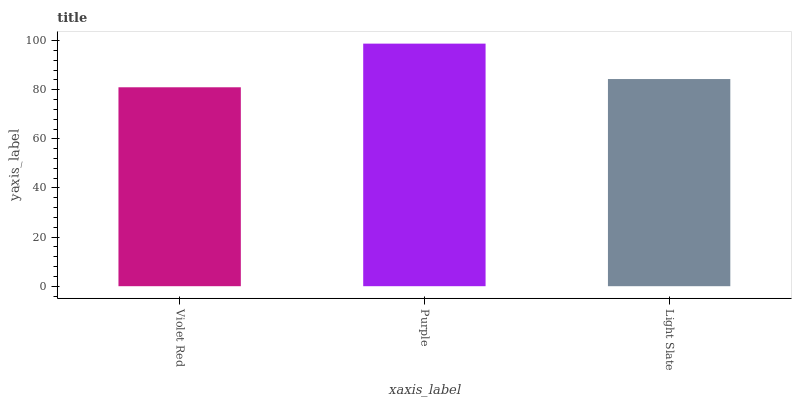Is Violet Red the minimum?
Answer yes or no. Yes. Is Purple the maximum?
Answer yes or no. Yes. Is Light Slate the minimum?
Answer yes or no. No. Is Light Slate the maximum?
Answer yes or no. No. Is Purple greater than Light Slate?
Answer yes or no. Yes. Is Light Slate less than Purple?
Answer yes or no. Yes. Is Light Slate greater than Purple?
Answer yes or no. No. Is Purple less than Light Slate?
Answer yes or no. No. Is Light Slate the high median?
Answer yes or no. Yes. Is Light Slate the low median?
Answer yes or no. Yes. Is Purple the high median?
Answer yes or no. No. Is Violet Red the low median?
Answer yes or no. No. 